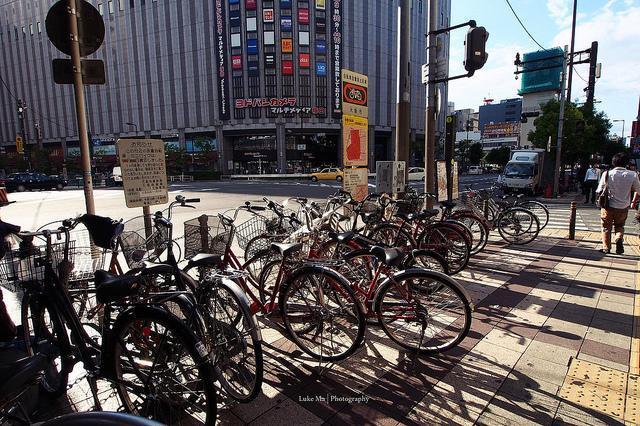How many bicycles can you see?
Give a very brief answer. 9. How many zebras are in the photograph?
Give a very brief answer. 0. 